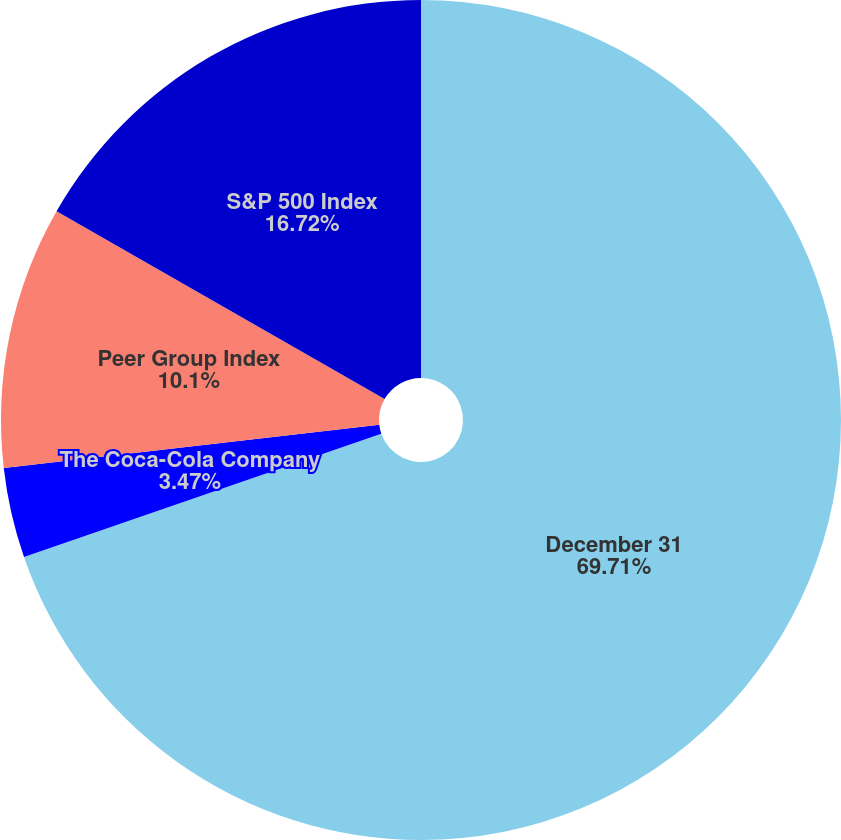Convert chart to OTSL. <chart><loc_0><loc_0><loc_500><loc_500><pie_chart><fcel>December 31<fcel>The Coca-Cola Company<fcel>Peer Group Index<fcel>S&P 500 Index<nl><fcel>69.71%<fcel>3.47%<fcel>10.1%<fcel>16.72%<nl></chart> 